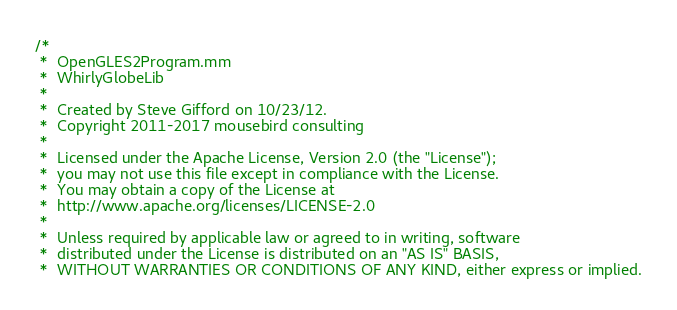<code> <loc_0><loc_0><loc_500><loc_500><_ObjectiveC_>/*
 *  OpenGLES2Program.mm
 *  WhirlyGlobeLib
 *
 *  Created by Steve Gifford on 10/23/12.
 *  Copyright 2011-2017 mousebird consulting
 *
 *  Licensed under the Apache License, Version 2.0 (the "License");
 *  you may not use this file except in compliance with the License.
 *  You may obtain a copy of the License at
 *  http://www.apache.org/licenses/LICENSE-2.0
 *
 *  Unless required by applicable law or agreed to in writing, software
 *  distributed under the License is distributed on an "AS IS" BASIS,
 *  WITHOUT WARRANTIES OR CONDITIONS OF ANY KIND, either express or implied.</code> 